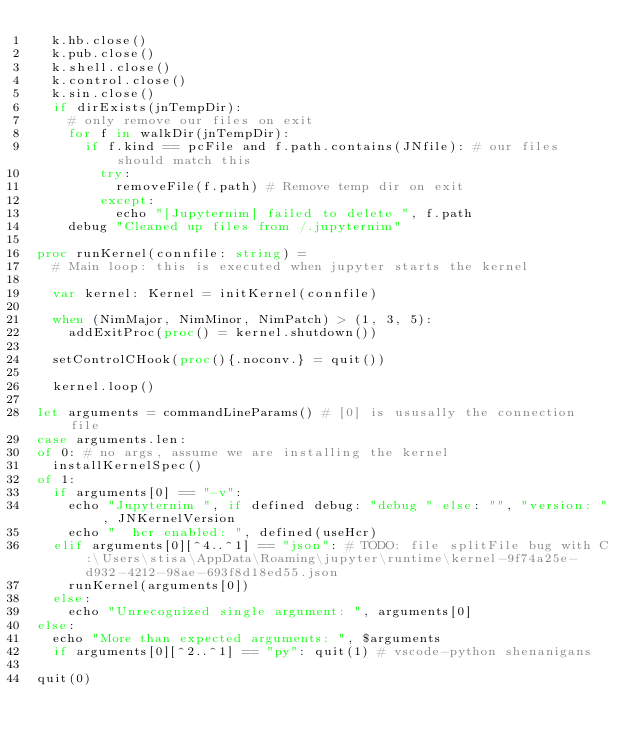<code> <loc_0><loc_0><loc_500><loc_500><_Nim_>  k.hb.close()
  k.pub.close()
  k.shell.close()
  k.control.close()
  k.sin.close()
  if dirExists(jnTempDir):
    # only remove our files on exit
    for f in walkDir(jnTempDir):
      if f.kind == pcFile and f.path.contains(JNfile): # our files should match this
        try:
          removeFile(f.path) # Remove temp dir on exit
        except:
          echo "[Jupyternim] failed to delete ", f.path
    debug "Cleaned up files from /.jupyternim"

proc runKernel(connfile: string) =
  # Main loop: this is executed when jupyter starts the kernel

  var kernel: Kernel = initKernel(connfile)

  when (NimMajor, NimMinor, NimPatch) > (1, 3, 5):
    addExitProc(proc() = kernel.shutdown())

  setControlCHook(proc(){.noconv.} = quit())

  kernel.loop()

let arguments = commandLineParams() # [0] is ususally the connection file
case arguments.len:
of 0: # no args, assume we are installing the kernel
  installKernelSpec()
of 1:
  if arguments[0] == "-v":
    echo "Jupyternim ", if defined debug: "debug " else: "", "version: ", JNKernelVersion
    echo "  hcr enabled: ", defined(useHcr)
  elif arguments[0][^4..^1] == "json": # TODO: file splitFile bug with C:\Users\stisa\AppData\Roaming\jupyter\runtime\kernel-9f74a25e-d932-4212-98ae-693f8d18ed55.json
    runKernel(arguments[0])
  else:
    echo "Unrecognized single argument: ", arguments[0]
else:
  echo "More than expected arguments: ", $arguments
  if arguments[0][^2..^1] == "py": quit(1) # vscode-python shenanigans

quit(0)
</code> 